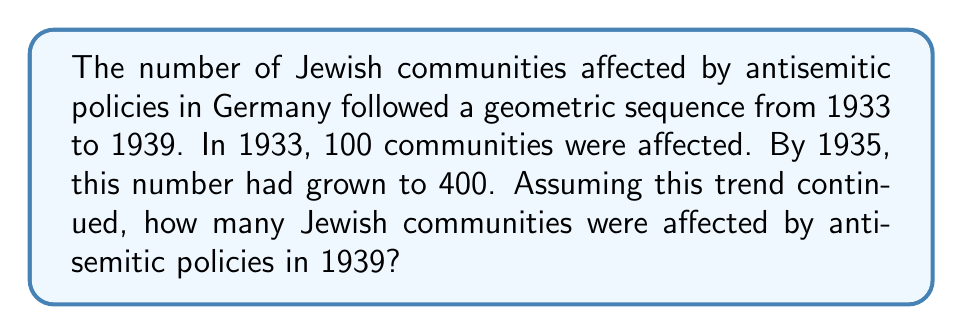What is the answer to this math problem? 1. Identify the geometric sequence:
   - First term (1933): $a = 100$
   - Second term (1935): $ar = 400$

2. Calculate the common ratio:
   $r = \frac{400}{100} = 4$

3. Determine the number of terms:
   - 1933 to 1939 is 6 years
   - $n = 6 + 1 = 7$ (including the initial year)

4. Use the geometric sequence formula:
   $a_n = ar^{n-1}$

5. Substitute the values:
   $a_7 = 100 \cdot 4^{7-1}$

6. Calculate:
   $a_7 = 100 \cdot 4^6 = 100 \cdot 4096 = 409,600$
Answer: 409,600 